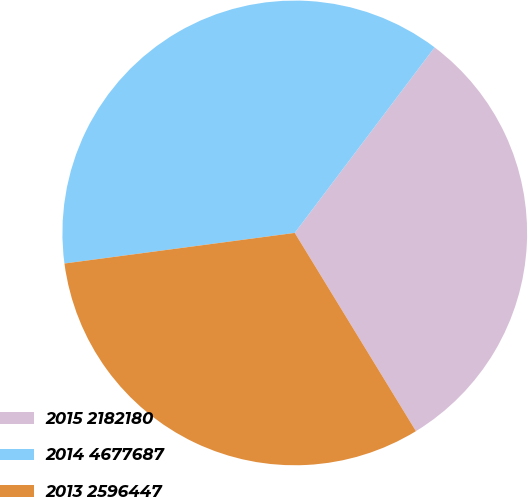Convert chart to OTSL. <chart><loc_0><loc_0><loc_500><loc_500><pie_chart><fcel>2015 2182180<fcel>2014 4677687<fcel>2013 2596447<nl><fcel>30.99%<fcel>37.38%<fcel>31.63%<nl></chart> 